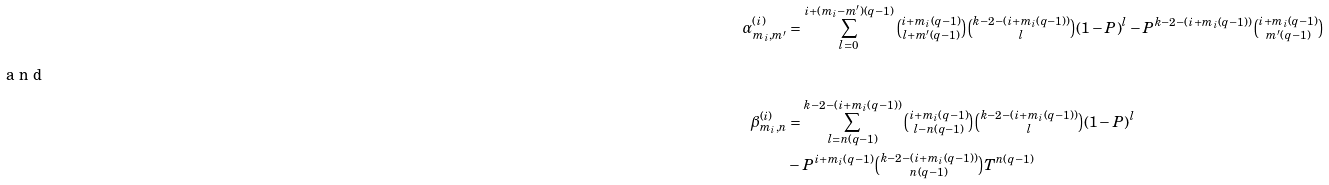<formula> <loc_0><loc_0><loc_500><loc_500>\alpha _ { m _ { i } , m ^ { \prime } } ^ { ( i ) } & = \sum _ { l = 0 } ^ { i + ( m _ { i } - m ^ { \prime } ) ( q - 1 ) } \tbinom { i + m _ { i } ( q - 1 ) } { l + m ^ { \prime } ( q - 1 ) } \tbinom { k - 2 - ( i + m _ { i } ( q - 1 ) ) } { l } ( 1 - P ) ^ { l } - P ^ { k - 2 - ( i + m _ { i } ( q - 1 ) ) } \tbinom { i + m _ { i } ( q - 1 ) } { m ^ { \prime } ( q - 1 ) } \\ \intertext { a n d } \beta _ { m _ { i } , n } ^ { ( i ) } & = \sum _ { l = n ( q - 1 ) } ^ { k - 2 - ( i + m _ { i } ( q - 1 ) ) } \tbinom { i + m _ { i } ( q - 1 ) } { l - n ( q - 1 ) } \tbinom { k - 2 - ( i + m _ { i } ( q - 1 ) ) } { l } ( 1 - P ) ^ { l } \\ & - P ^ { i + m _ { i } ( q - 1 ) } \tbinom { k - 2 - ( i + m _ { i } ( q - 1 ) ) } { n ( q - 1 ) } T ^ { n ( q - 1 ) }</formula> 